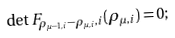Convert formula to latex. <formula><loc_0><loc_0><loc_500><loc_500>\det F _ { \rho _ { \mu - 1 , i } - \rho _ { \mu , i } , i } ( \rho _ { \mu , i } ) = 0 ;</formula> 